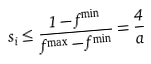<formula> <loc_0><loc_0><loc_500><loc_500>s _ { i } \leq \frac { 1 - f ^ { \min } } { f ^ { \max } - f ^ { \min } } = \frac { 4 } { a }</formula> 